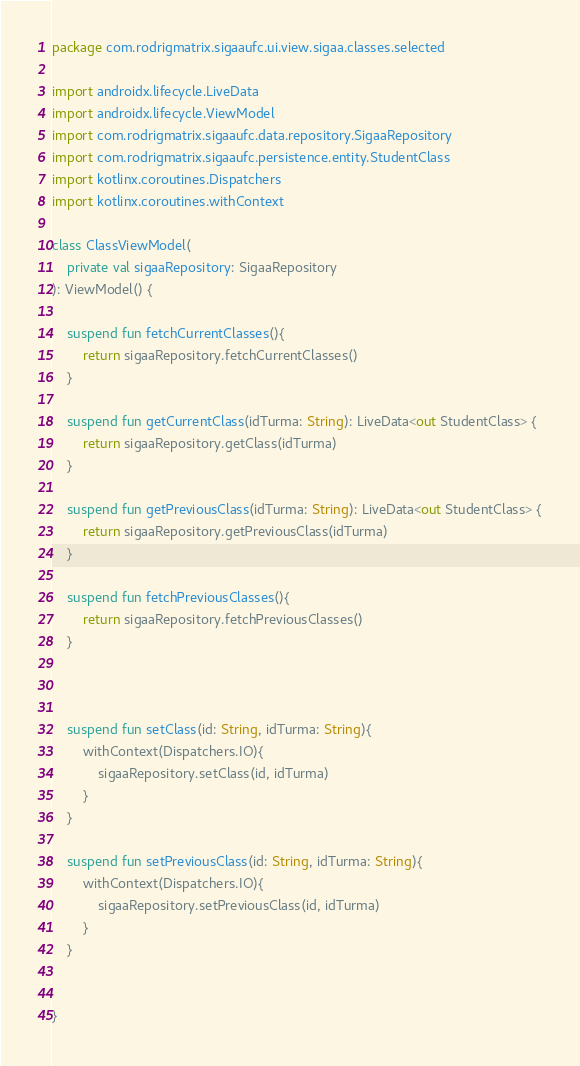Convert code to text. <code><loc_0><loc_0><loc_500><loc_500><_Kotlin_>package com.rodrigmatrix.sigaaufc.ui.view.sigaa.classes.selected

import androidx.lifecycle.LiveData
import androidx.lifecycle.ViewModel
import com.rodrigmatrix.sigaaufc.data.repository.SigaaRepository
import com.rodrigmatrix.sigaaufc.persistence.entity.StudentClass
import kotlinx.coroutines.Dispatchers
import kotlinx.coroutines.withContext

class ClassViewModel(
    private val sigaaRepository: SigaaRepository
): ViewModel() {

    suspend fun fetchCurrentClasses(){
        return sigaaRepository.fetchCurrentClasses()
    }

    suspend fun getCurrentClass(idTurma: String): LiveData<out StudentClass> {
        return sigaaRepository.getClass(idTurma)
    }

    suspend fun getPreviousClass(idTurma: String): LiveData<out StudentClass> {
        return sigaaRepository.getPreviousClass(idTurma)
    }

    suspend fun fetchPreviousClasses(){
        return sigaaRepository.fetchPreviousClasses()
    }



    suspend fun setClass(id: String, idTurma: String){
        withContext(Dispatchers.IO){
            sigaaRepository.setClass(id, idTurma)
        }
    }

    suspend fun setPreviousClass(id: String, idTurma: String){
        withContext(Dispatchers.IO){
            sigaaRepository.setPreviousClass(id, idTurma)
        }
    }


}</code> 